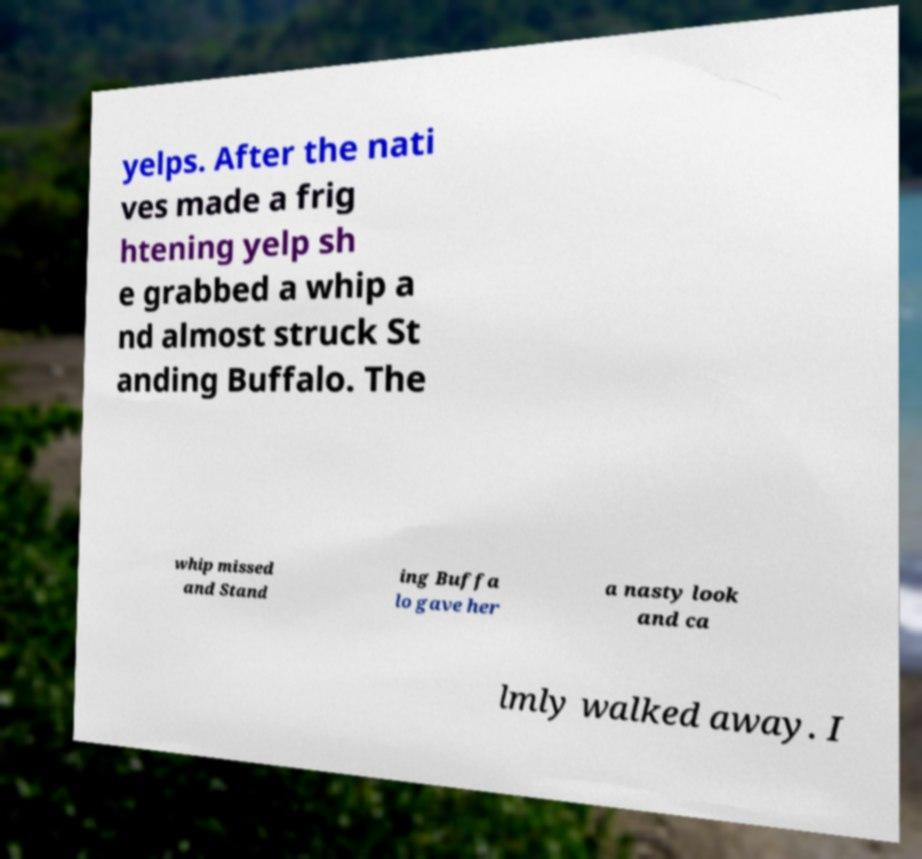For documentation purposes, I need the text within this image transcribed. Could you provide that? yelps. After the nati ves made a frig htening yelp sh e grabbed a whip a nd almost struck St anding Buffalo. The whip missed and Stand ing Buffa lo gave her a nasty look and ca lmly walked away. I 